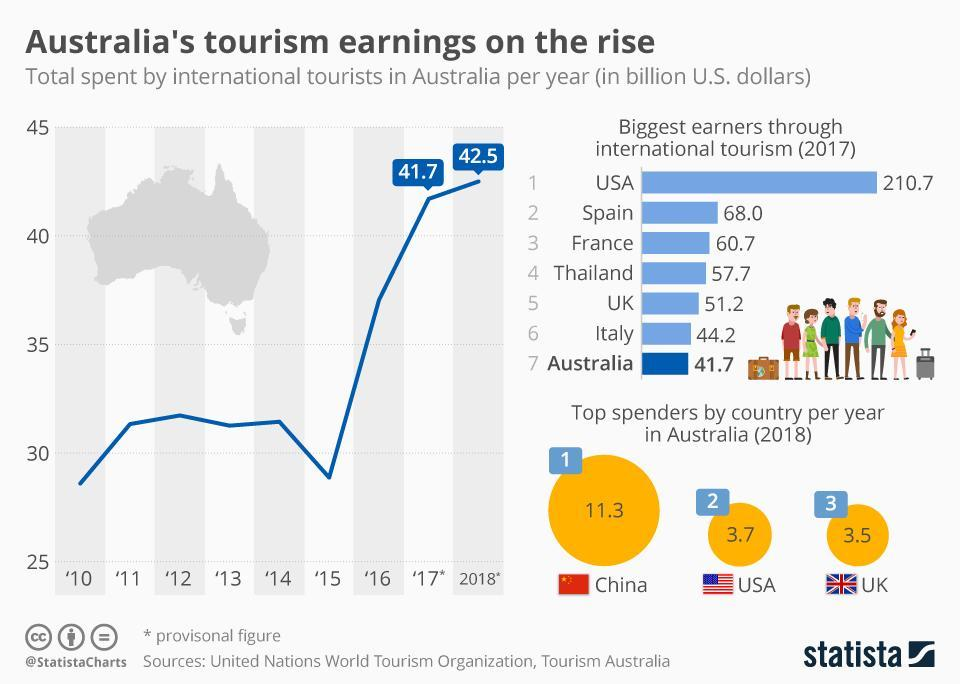Who was the biggest earner in 2017 through international tourism?
Answer the question with a short phrase. USA Which year did Australia earn maximum in tourism? 2018 Which country is third in spending in Australia? UK 